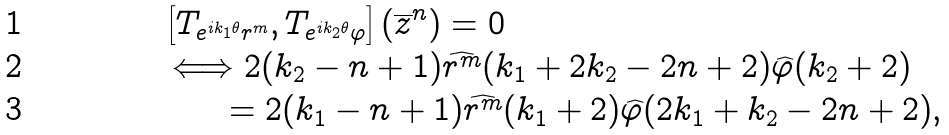Convert formula to latex. <formula><loc_0><loc_0><loc_500><loc_500>& \left [ T _ { e ^ { i k _ { 1 } \theta } r ^ { m } } , T _ { e ^ { i k _ { 2 } \theta } \varphi } \right ] ( \overline { z } ^ { n } ) = 0 \\ & \Longleftrightarrow 2 ( k _ { 2 } - n + 1 ) \widehat { r ^ { m } } ( k _ { 1 } + 2 k _ { 2 } - 2 n + 2 ) \widehat { \varphi } ( k _ { 2 } + 2 ) \\ & \quad \ \ = 2 ( k _ { 1 } - n + 1 ) \widehat { r ^ { m } } ( k _ { 1 } + 2 ) \widehat { \varphi } ( 2 k _ { 1 } + k _ { 2 } - 2 n + 2 ) ,</formula> 